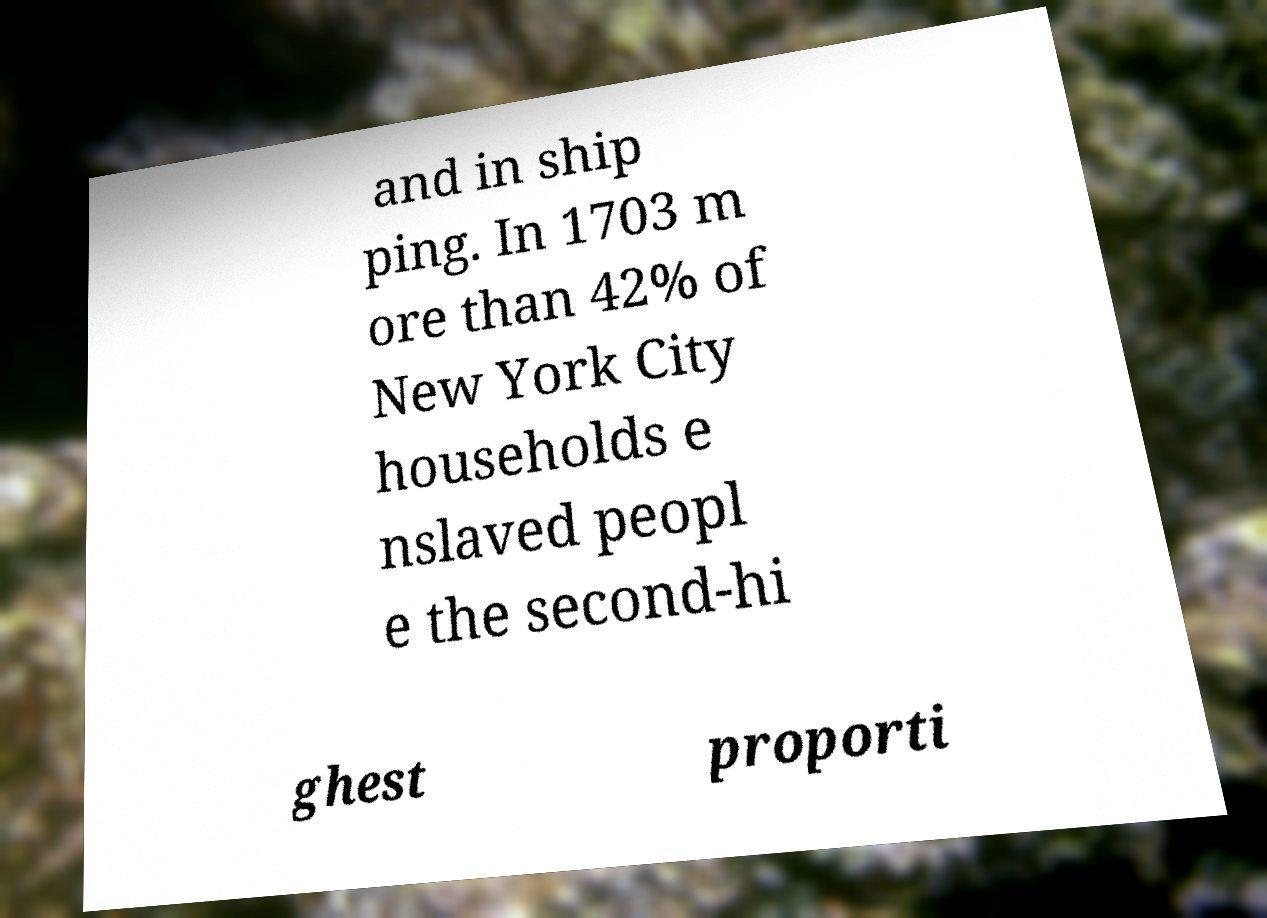Can you accurately transcribe the text from the provided image for me? and in ship ping. In 1703 m ore than 42% of New York City households e nslaved peopl e the second-hi ghest proporti 